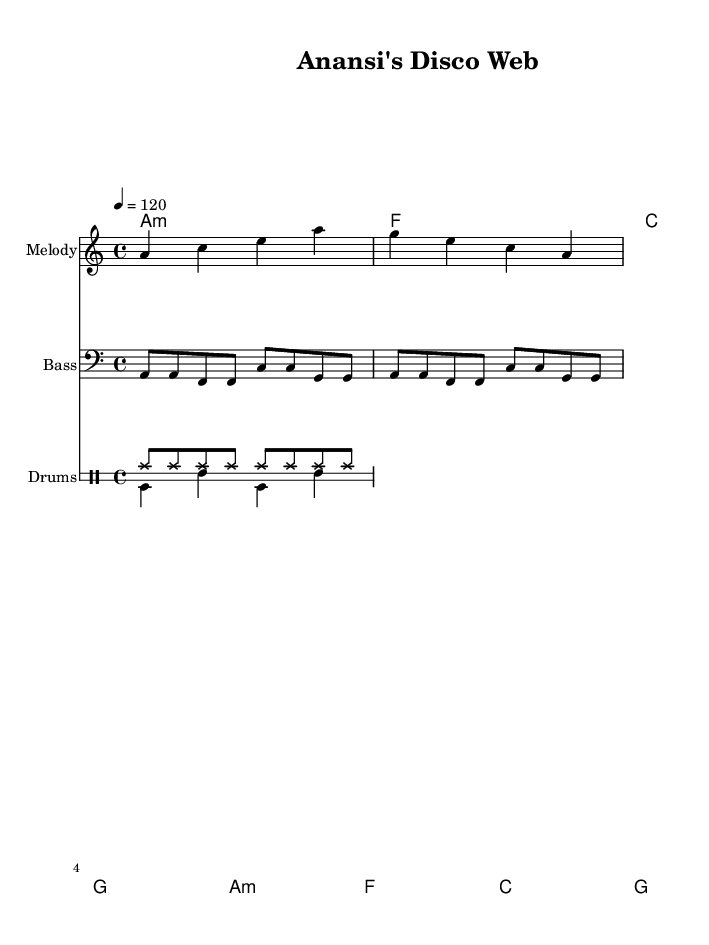What is the key signature of this music? The key signature is A minor, which has no sharps or flats, indicated at the beginning of the sheet music in the key signature section.
Answer: A minor What is the time signature of this music? The time signature is 4/4, which indicates that there are four beats per measure and the quarter note gets one beat, shown in the time signature section at the beginning of the sheet music.
Answer: 4/4 What is the tempo of this piece? The tempo is indicated as 120 beats per minute (BPM), shown at the start of the music. This means the piece should be played at a moderate speed.
Answer: 120 How many measures are there in the melody? Counting the number of complete sets of notes and rests indicates there are two measures in the melody section as displayed.
Answer: 2 What type of dance rhythm is represented by the drum section? The drum section includes bass drum and snare patterns typical in disco music, which emphasizes the dance rhythm suitable for club settings.
Answer: Disco What are the chord changes in this piece? The chord changes in the chord names section display the sequence A minor, F major, C major, and G major, which repeat throughout.
Answer: A minor, F major, C major, G major What instrument is featured as a melody in the score? The melody feature is presented for a single staff named "Melody", which plays the main theme throughout the piece.
Answer: Melody 